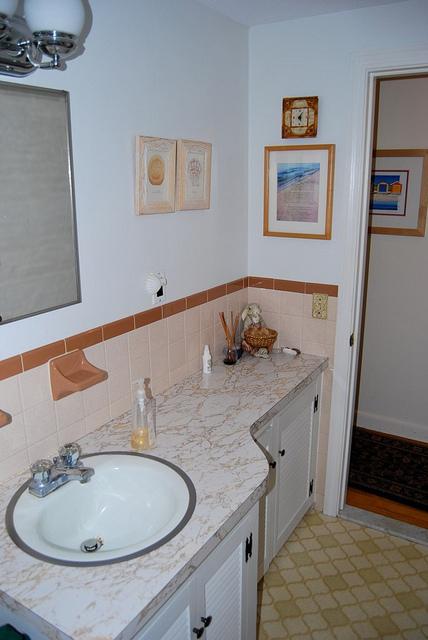Where does the open doorway lead to?
Write a very short answer. Hallway. What room is this in?
Concise answer only. Bathroom. What type of flooring is in the room?
Short answer required. Tile. 